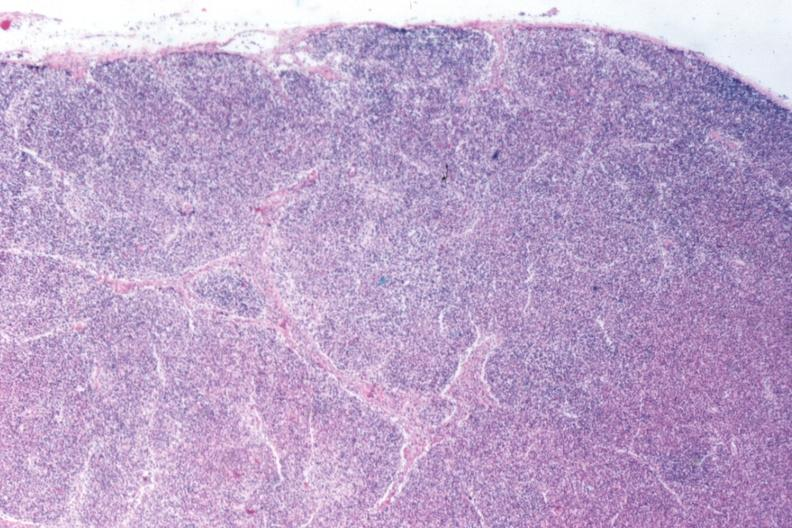s bone, mandible present?
Answer the question using a single word or phrase. No 